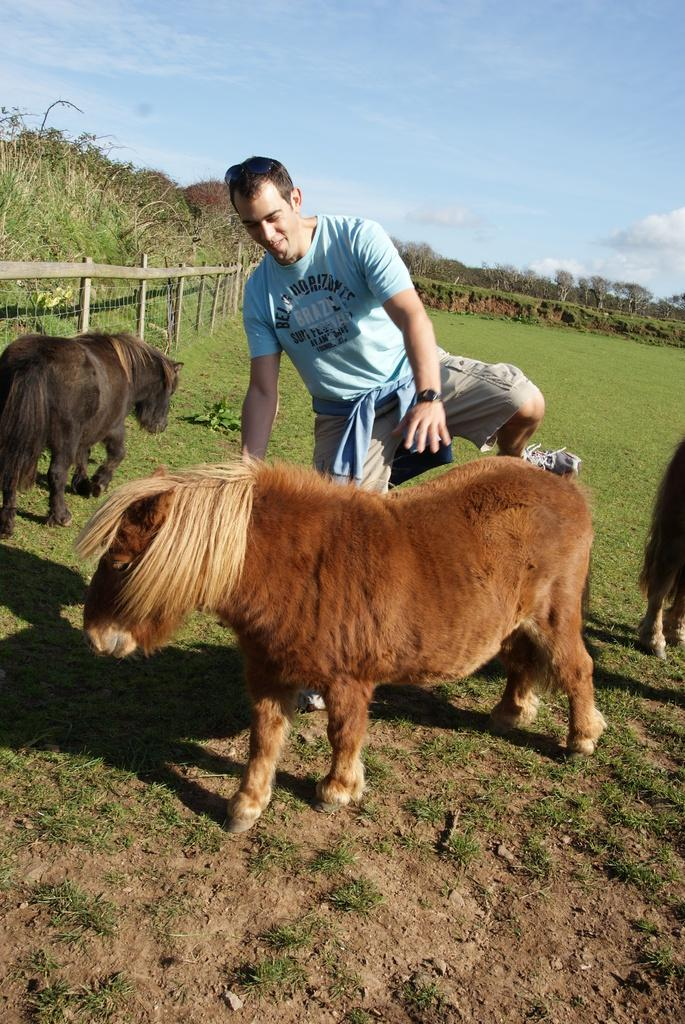Who is present in the image? There is a man in the image. What other living beings can be seen in the image? There are animals in the image. What can be seen in the distance in the image? There are trees in the background of the image. What part of the natural environment is visible in the image? The sky is visible in the background of the image. What type of jam is being spread on the page in the image? There is no page or jam present in the image. What trail is visible in the image? There is no trail visible in the image. 